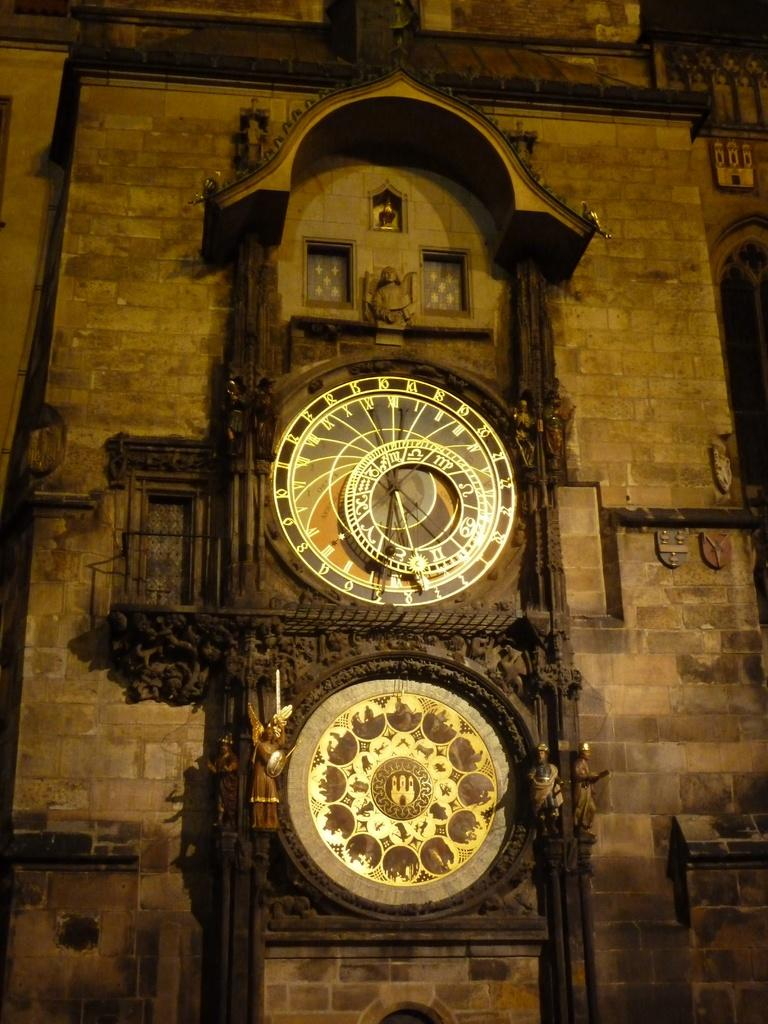What object is located in the middle of the image? There is a clock in the middle of the image. What else can be seen in the image besides the clock? There are dolls on the wall in the image. What type of nut is being sold in the shop in the image? There is no shop or nut present in the image; it features a clock and dolls on the wall. What kind of music is the band playing in the background of the image? There is no band or music present in the image; it features a clock and dolls on the wall. 